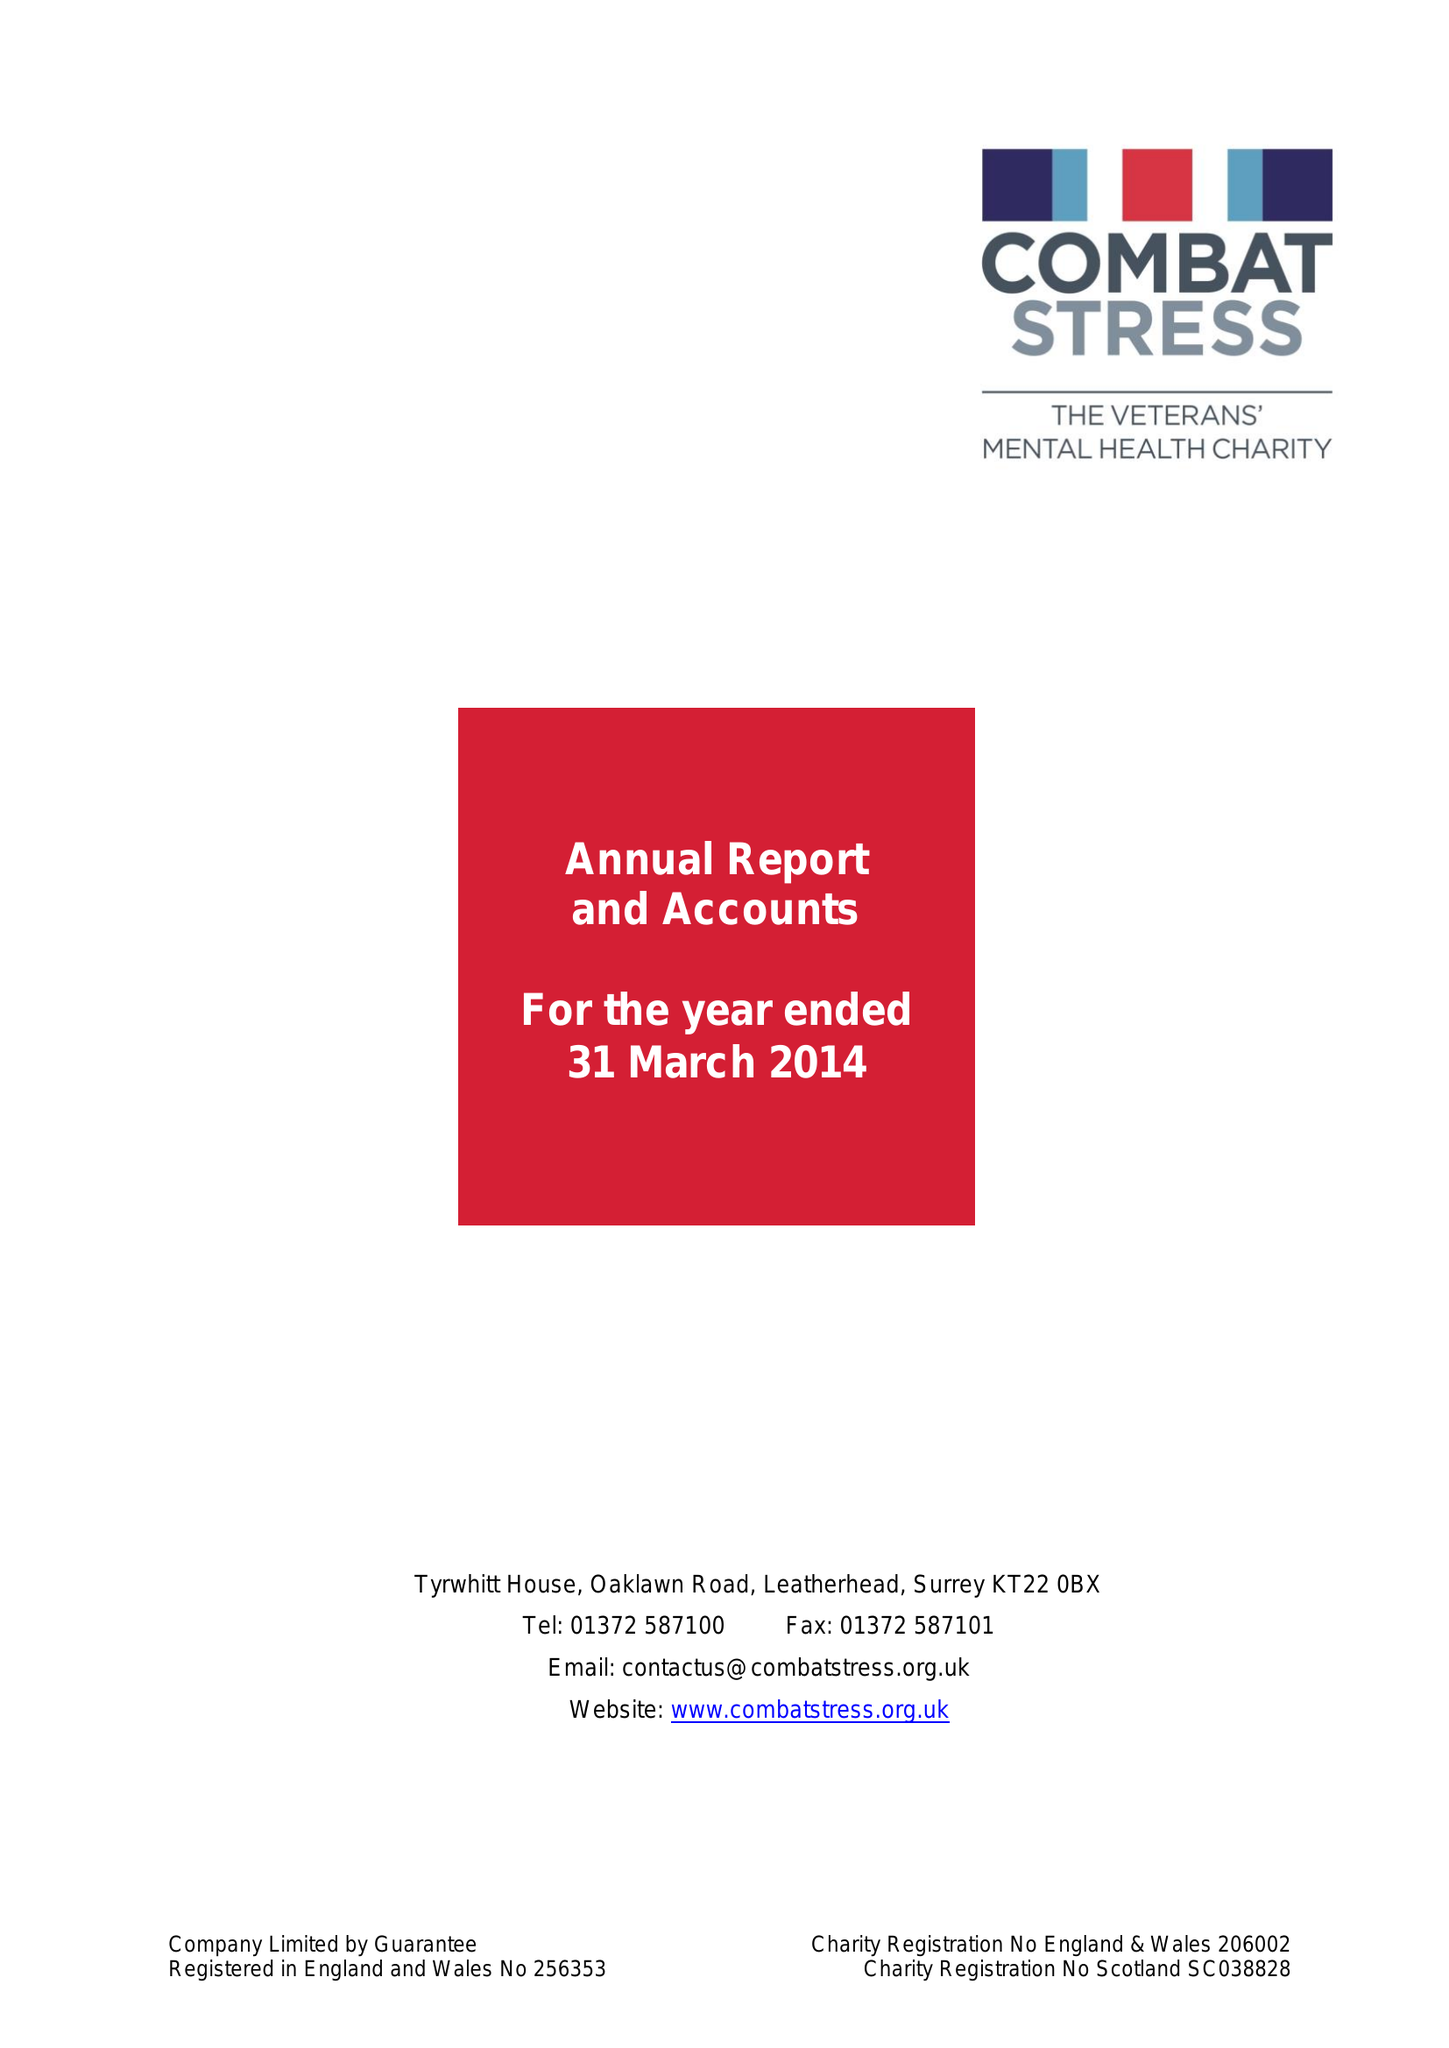What is the value for the charity_name?
Answer the question using a single word or phrase. Combat Stress 